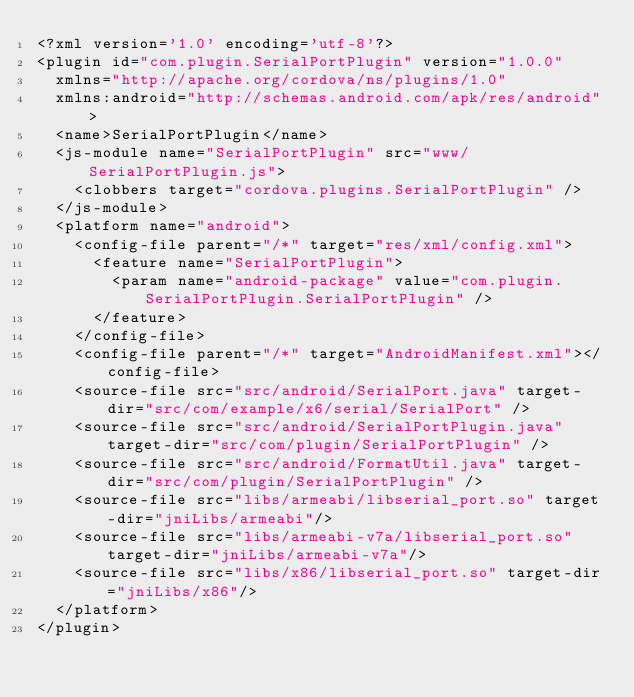Convert code to text. <code><loc_0><loc_0><loc_500><loc_500><_XML_><?xml version='1.0' encoding='utf-8'?>
<plugin id="com.plugin.SerialPortPlugin" version="1.0.0"
  xmlns="http://apache.org/cordova/ns/plugins/1.0"
  xmlns:android="http://schemas.android.com/apk/res/android">
  <name>SerialPortPlugin</name>
  <js-module name="SerialPortPlugin" src="www/SerialPortPlugin.js">
    <clobbers target="cordova.plugins.SerialPortPlugin" />
  </js-module>
  <platform name="android">
    <config-file parent="/*" target="res/xml/config.xml">
      <feature name="SerialPortPlugin">
        <param name="android-package" value="com.plugin.SerialPortPlugin.SerialPortPlugin" />
      </feature>
    </config-file>
    <config-file parent="/*" target="AndroidManifest.xml"></config-file>
    <source-file src="src/android/SerialPort.java" target-dir="src/com/example/x6/serial/SerialPort" />
    <source-file src="src/android/SerialPortPlugin.java" target-dir="src/com/plugin/SerialPortPlugin" />
    <source-file src="src/android/FormatUtil.java" target-dir="src/com/plugin/SerialPortPlugin" />
    <source-file src="libs/armeabi/libserial_port.so" target-dir="jniLibs/armeabi"/>
    <source-file src="libs/armeabi-v7a/libserial_port.so" target-dir="jniLibs/armeabi-v7a"/>
    <source-file src="libs/x86/libserial_port.so" target-dir="jniLibs/x86"/>
  </platform>
</plugin>
</code> 